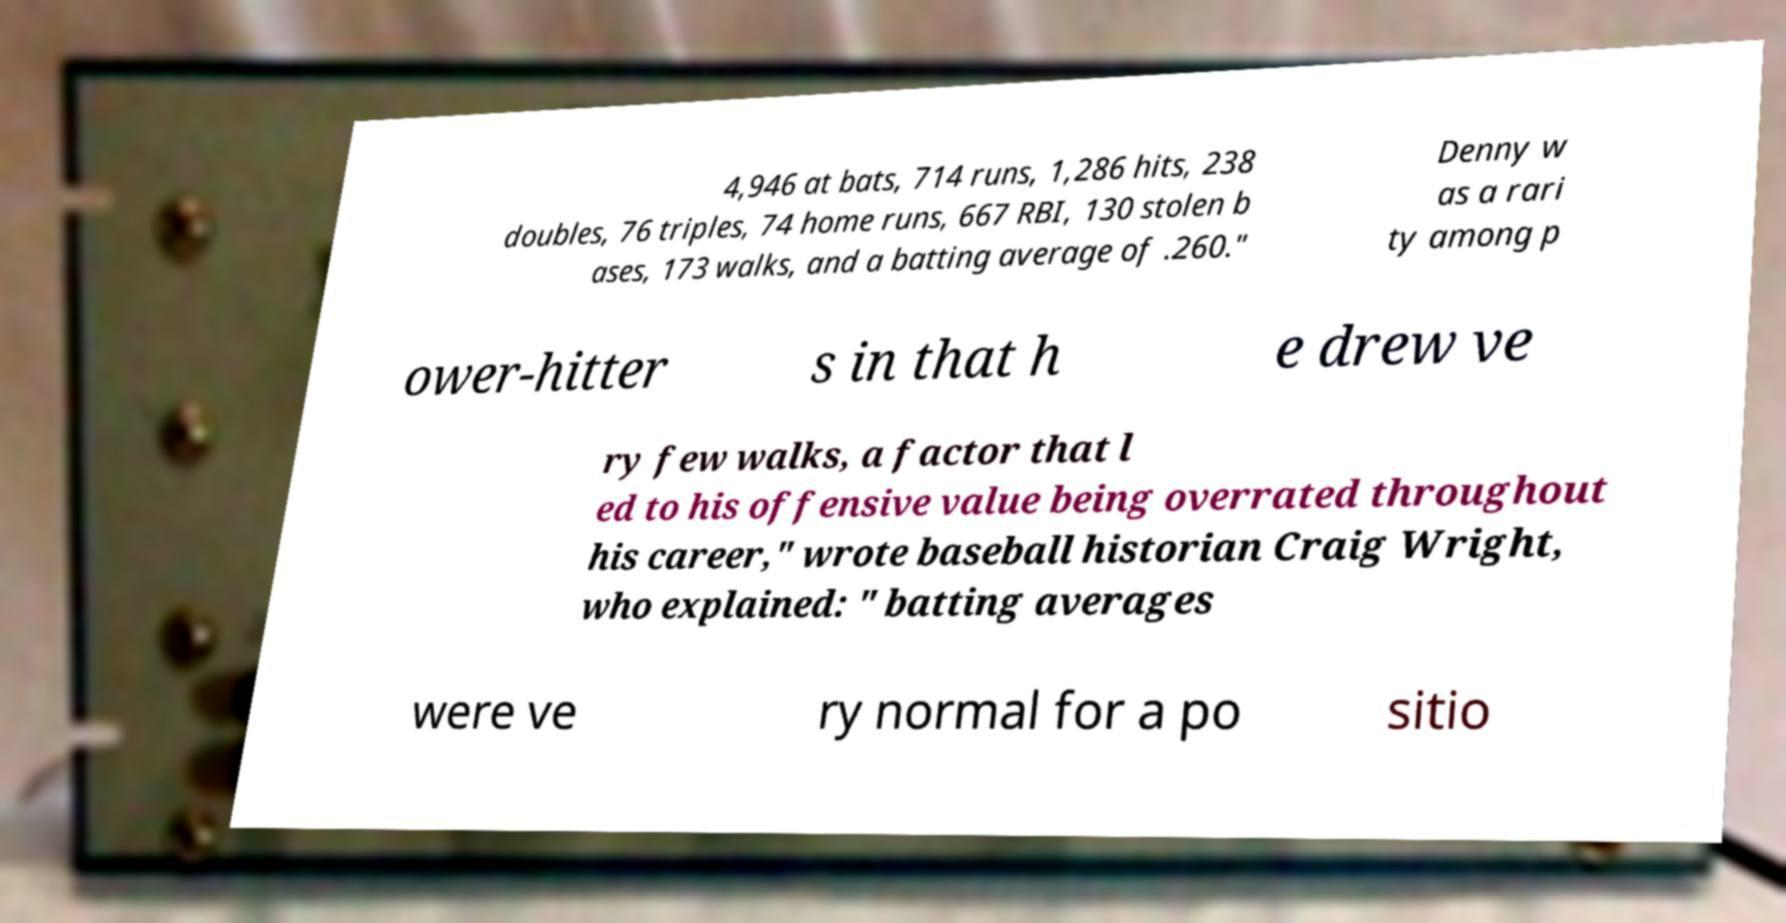Can you read and provide the text displayed in the image?This photo seems to have some interesting text. Can you extract and type it out for me? 4,946 at bats, 714 runs, 1,286 hits, 238 doubles, 76 triples, 74 home runs, 667 RBI, 130 stolen b ases, 173 walks, and a batting average of .260." Denny w as a rari ty among p ower-hitter s in that h e drew ve ry few walks, a factor that l ed to his offensive value being overrated throughout his career," wrote baseball historian Craig Wright, who explained: " batting averages were ve ry normal for a po sitio 